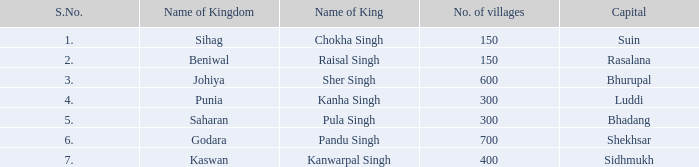What kingdom has suin as its main city? Sihag. 